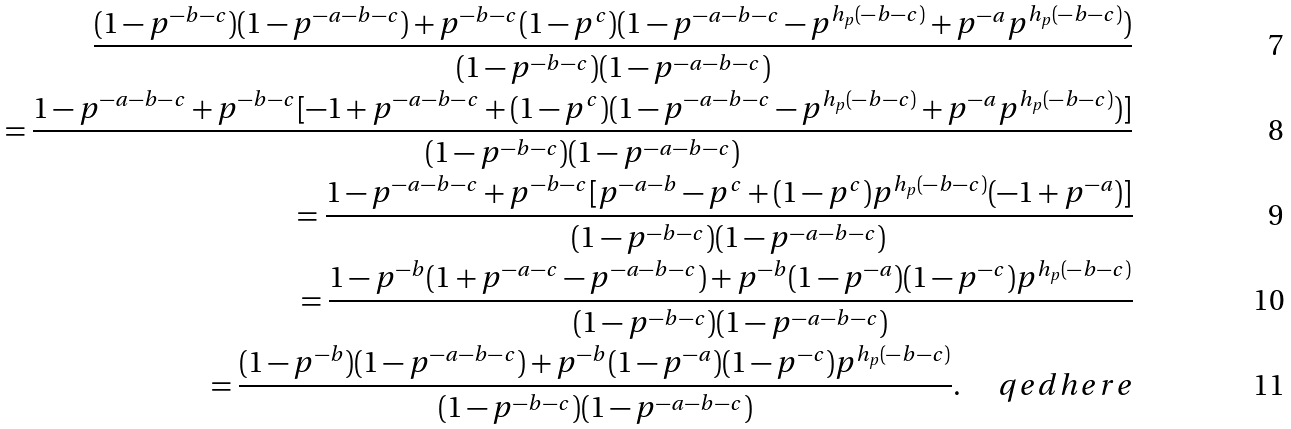<formula> <loc_0><loc_0><loc_500><loc_500>\frac { ( 1 - p ^ { - b - c } ) ( 1 - p ^ { - a - b - c } ) + p ^ { - b - c } ( 1 - p ^ { c } ) ( 1 - p ^ { - a - b - c } - p ^ { h _ { p } ( - b - c ) } + p ^ { - a } p ^ { h _ { p } ( - b - c ) } ) } { ( 1 - p ^ { - b - c } ) ( 1 - p ^ { - a - b - c } ) } \\ = \frac { 1 - p ^ { - a - b - c } + p ^ { - b - c } [ - 1 + p ^ { - a - b - c } + ( 1 - p ^ { c } ) ( 1 - p ^ { - a - b - c } - p ^ { h _ { p } ( - b - c ) } + p ^ { - a } p ^ { h _ { p } ( - b - c ) } ) ] } { ( 1 - p ^ { - b - c } ) ( 1 - p ^ { - a - b - c } ) } \\ = \frac { 1 - p ^ { - a - b - c } + p ^ { - b - c } [ p ^ { - a - b } - p ^ { c } + ( 1 - p ^ { c } ) p ^ { h _ { p } ( - b - c ) } ( - 1 + p ^ { - a } ) ] } { ( 1 - p ^ { - b - c } ) ( 1 - p ^ { - a - b - c } ) } \\ = \frac { 1 - p ^ { - b } ( 1 + p ^ { - a - c } - p ^ { - a - b - c } ) + p ^ { - b } ( 1 - p ^ { - a } ) ( 1 - p ^ { - c } ) p ^ { h _ { p } ( - b - c ) } } { ( 1 - p ^ { - b - c } ) ( 1 - p ^ { - a - b - c } ) } \\ = \frac { ( 1 - p ^ { - b } ) ( 1 - p ^ { - a - b - c } ) + p ^ { - b } ( 1 - p ^ { - a } ) ( 1 - p ^ { - c } ) p ^ { h _ { p } ( - b - c ) } } { ( 1 - p ^ { - b - c } ) ( 1 - p ^ { - a - b - c } ) } . \quad \ q e d h e r e</formula> 